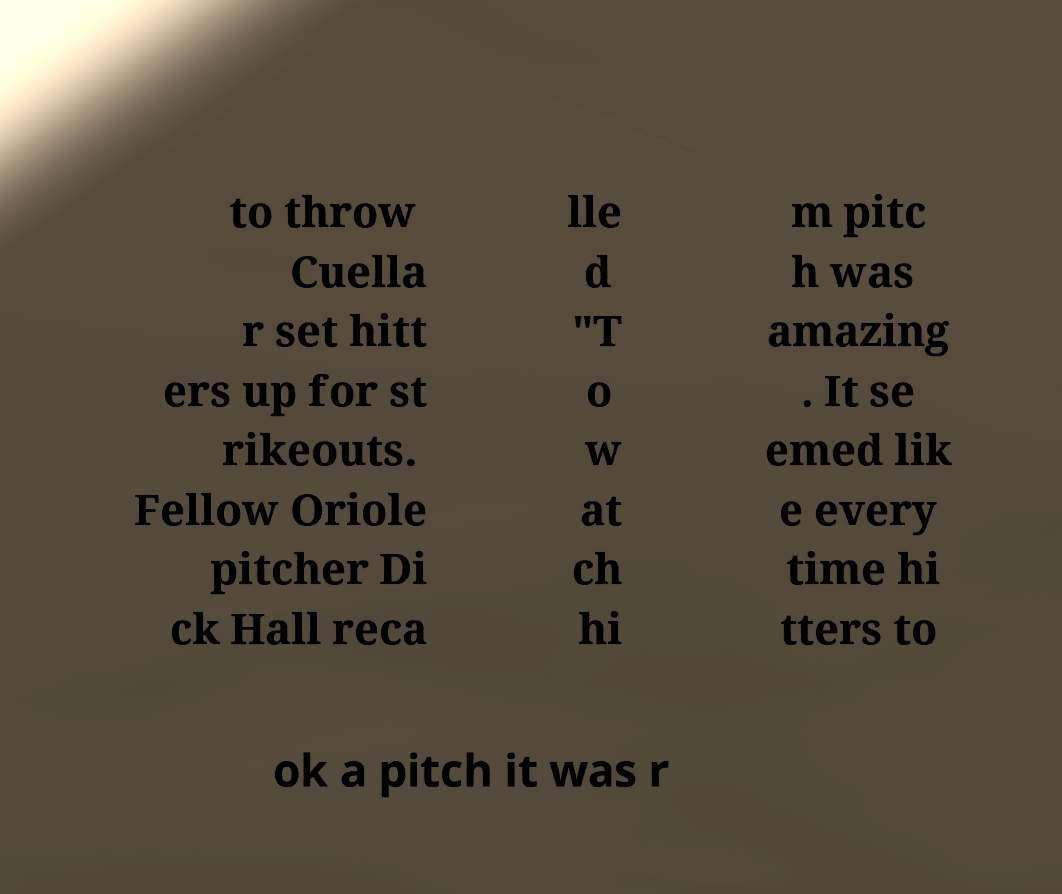Can you read and provide the text displayed in the image?This photo seems to have some interesting text. Can you extract and type it out for me? to throw Cuella r set hitt ers up for st rikeouts. Fellow Oriole pitcher Di ck Hall reca lle d "T o w at ch hi m pitc h was amazing . It se emed lik e every time hi tters to ok a pitch it was r 